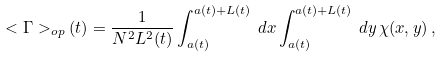Convert formula to latex. <formula><loc_0><loc_0><loc_500><loc_500>< \Gamma > _ { o p } ( t ) = \frac { 1 } { N ^ { 2 } L ^ { 2 } ( t ) } \int _ { a ( t ) } ^ { a ( t ) + L ( t ) } \, d x \int _ { a ( t ) } ^ { a ( t ) + L ( t ) } \, d y \, \chi ( x , y ) \, ,</formula> 